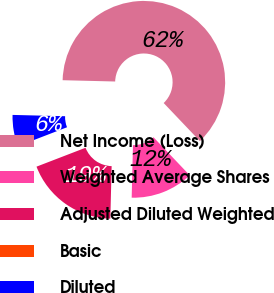Convert chart. <chart><loc_0><loc_0><loc_500><loc_500><pie_chart><fcel>Net Income (Loss)<fcel>Weighted Average Shares<fcel>Adjusted Diluted Weighted<fcel>Basic<fcel>Diluted<nl><fcel>62.5%<fcel>12.5%<fcel>18.75%<fcel>0.0%<fcel>6.25%<nl></chart> 